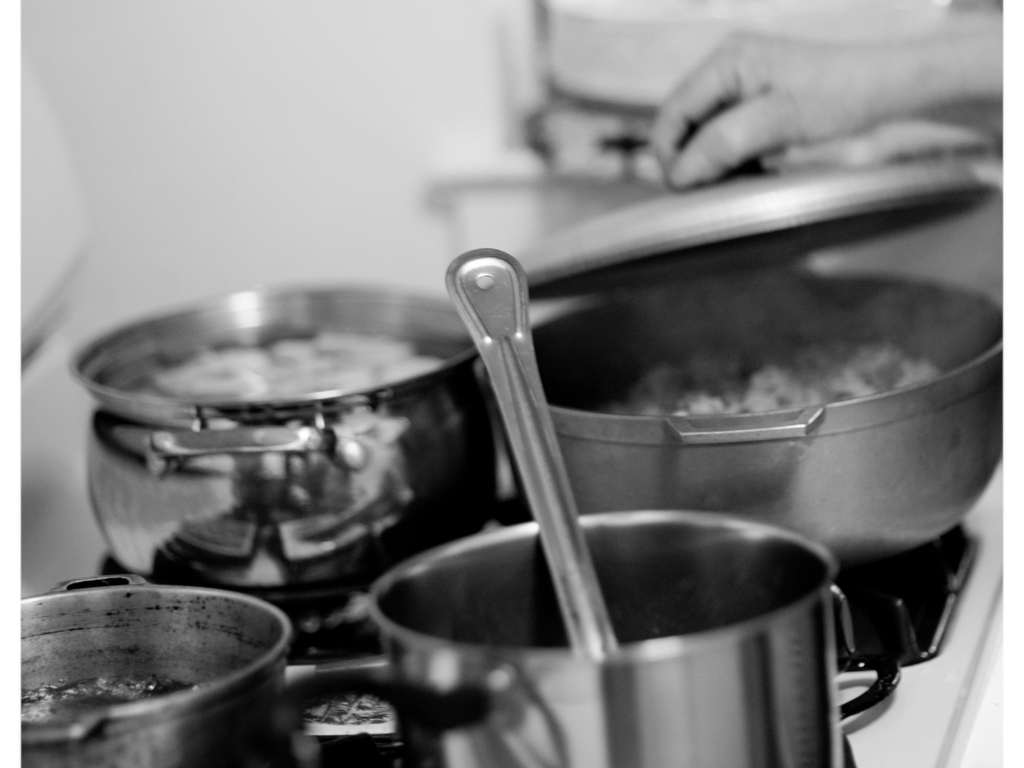Describe the composition and artistic elements present in this photograph. The photograph features a rich interplay of shadow and light in a monochromatic palette, highlighting the textures and varying sheens of multiple cooking pots. The steam rising from the pots adds a dynamic element, suggesting the warmth and activity inherent in cooking. The perspective chosen frames the scene in a way that portrays a candid glimpse into the kitchen, focusing closely on the objects while subtly capturing human interaction in the background. This choice of framing and focus effectively conveys a personal and intimate view of everyday culinary preparations. 